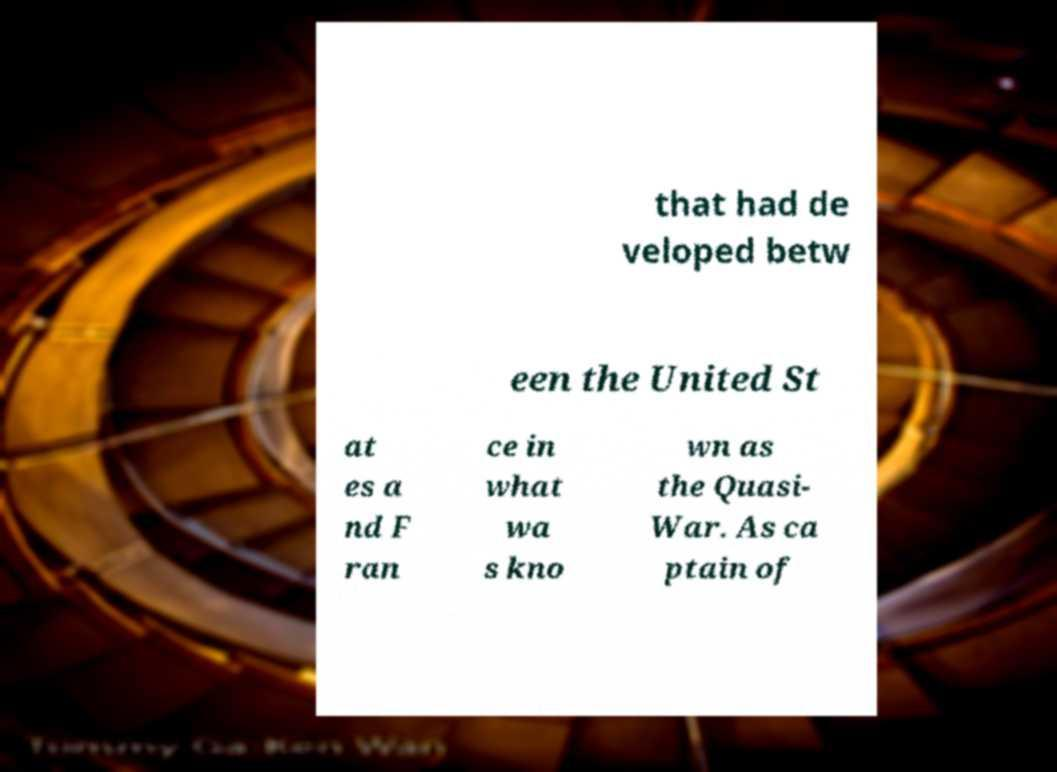Can you read and provide the text displayed in the image?This photo seems to have some interesting text. Can you extract and type it out for me? that had de veloped betw een the United St at es a nd F ran ce in what wa s kno wn as the Quasi- War. As ca ptain of 